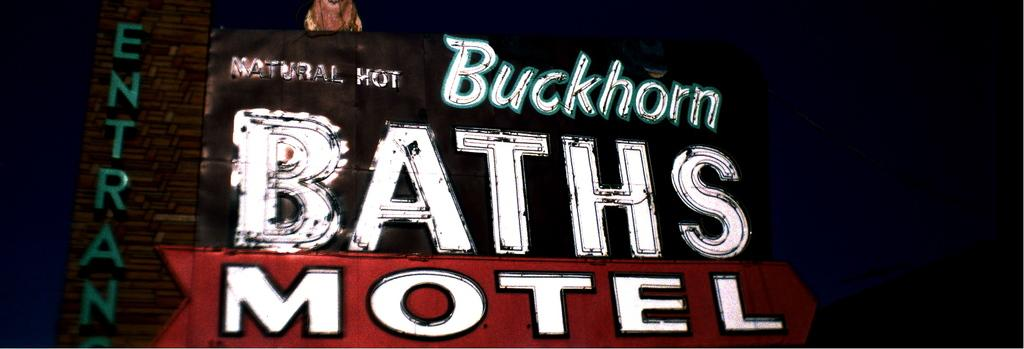<image>
Write a terse but informative summary of the picture. a Baths motel sign outside at night in white 